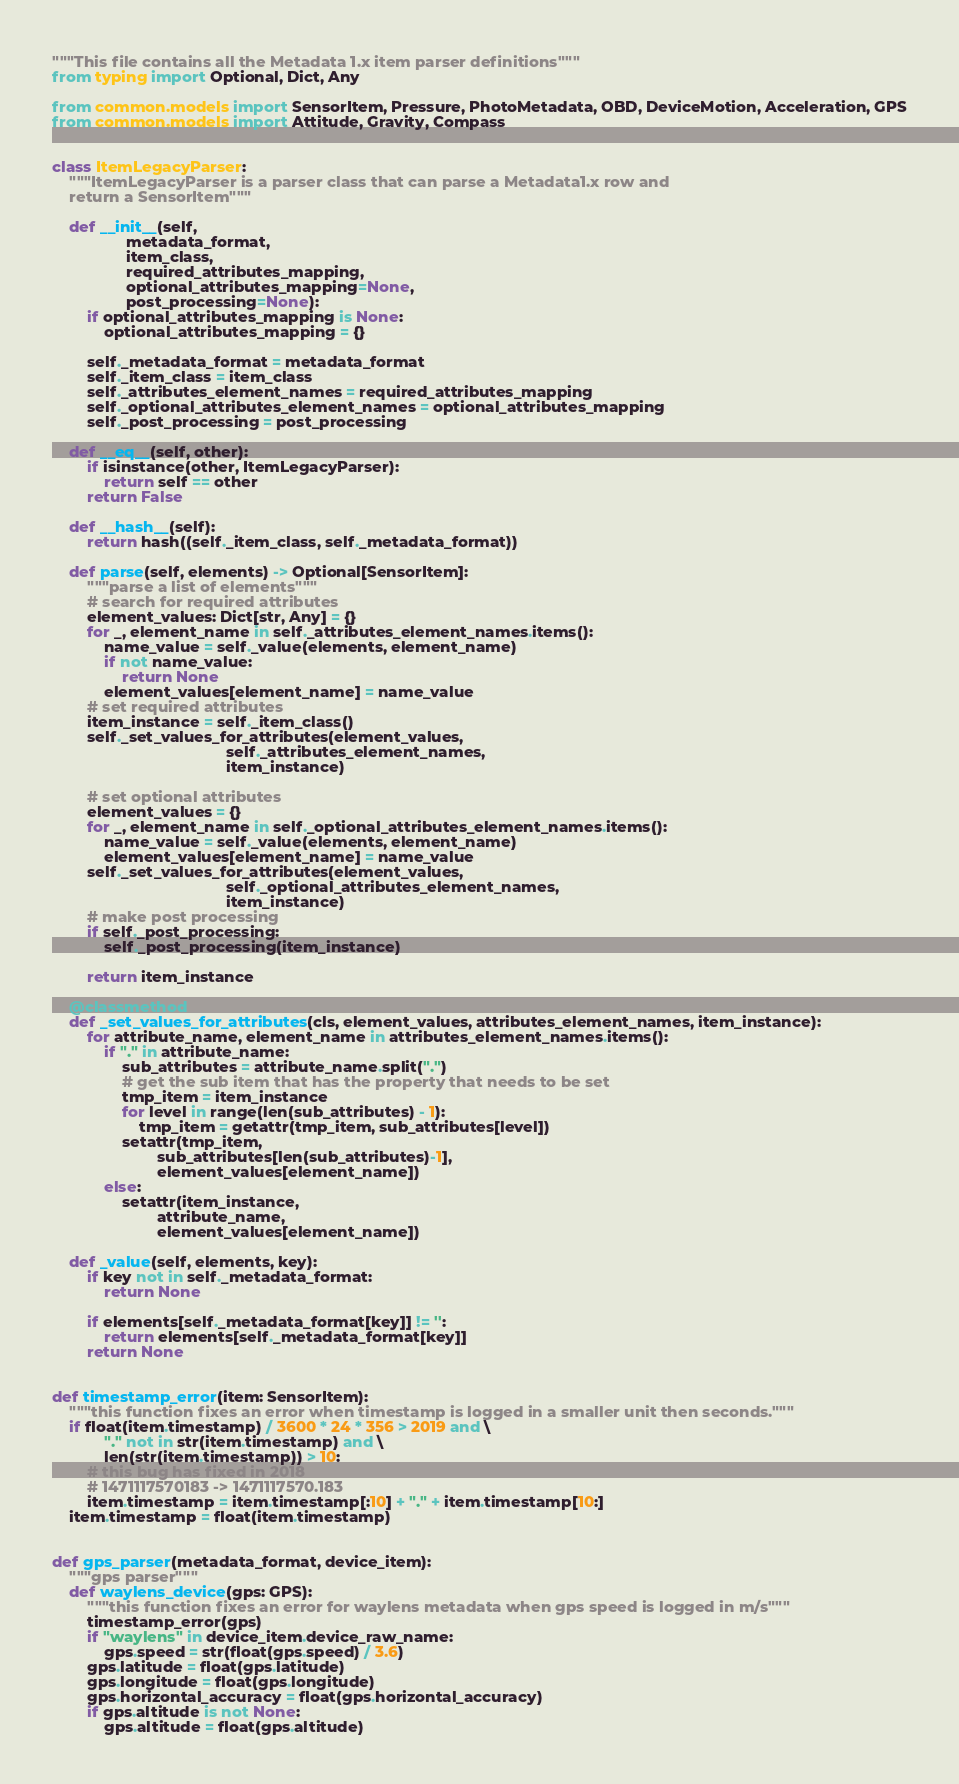Convert code to text. <code><loc_0><loc_0><loc_500><loc_500><_Python_>"""This file contains all the Metadata 1.x item parser definitions"""
from typing import Optional, Dict, Any

from common.models import SensorItem, Pressure, PhotoMetadata, OBD, DeviceMotion, Acceleration, GPS
from common.models import Attitude, Gravity, Compass


class ItemLegacyParser:
    """ItemLegacyParser is a parser class that can parse a Metadata1.x row and
    return a SensorItem"""

    def __init__(self,
                 metadata_format,
                 item_class,
                 required_attributes_mapping,
                 optional_attributes_mapping=None,
                 post_processing=None):
        if optional_attributes_mapping is None:
            optional_attributes_mapping = {}

        self._metadata_format = metadata_format
        self._item_class = item_class
        self._attributes_element_names = required_attributes_mapping
        self._optional_attributes_element_names = optional_attributes_mapping
        self._post_processing = post_processing

    def __eq__(self, other):
        if isinstance(other, ItemLegacyParser):
            return self == other
        return False

    def __hash__(self):
        return hash((self._item_class, self._metadata_format))

    def parse(self, elements) -> Optional[SensorItem]:
        """parse a list of elements"""
        # search for required attributes
        element_values: Dict[str, Any] = {}
        for _, element_name in self._attributes_element_names.items():
            name_value = self._value(elements, element_name)
            if not name_value:
                return None
            element_values[element_name] = name_value
        # set required attributes
        item_instance = self._item_class()
        self._set_values_for_attributes(element_values,
                                        self._attributes_element_names,
                                        item_instance)

        # set optional attributes
        element_values = {}
        for _, element_name in self._optional_attributes_element_names.items():
            name_value = self._value(elements, element_name)
            element_values[element_name] = name_value
        self._set_values_for_attributes(element_values,
                                        self._optional_attributes_element_names,
                                        item_instance)
        # make post processing
        if self._post_processing:
            self._post_processing(item_instance)

        return item_instance

    @classmethod
    def _set_values_for_attributes(cls, element_values, attributes_element_names, item_instance):
        for attribute_name, element_name in attributes_element_names.items():
            if "." in attribute_name:
                sub_attributes = attribute_name.split(".")
                # get the sub item that has the property that needs to be set
                tmp_item = item_instance
                for level in range(len(sub_attributes) - 1):
                    tmp_item = getattr(tmp_item, sub_attributes[level])
                setattr(tmp_item,
                        sub_attributes[len(sub_attributes)-1],
                        element_values[element_name])
            else:
                setattr(item_instance,
                        attribute_name,
                        element_values[element_name])

    def _value(self, elements, key):
        if key not in self._metadata_format:
            return None

        if elements[self._metadata_format[key]] != '':
            return elements[self._metadata_format[key]]
        return None


def timestamp_error(item: SensorItem):
    """this function fixes an error when timestamp is logged in a smaller unit then seconds."""
    if float(item.timestamp) / 3600 * 24 * 356 > 2019 and \
            "." not in str(item.timestamp) and \
            len(str(item.timestamp)) > 10:
        # this bug has fixed in 2018
        # 1471117570183 -> 1471117570.183
        item.timestamp = item.timestamp[:10] + "." + item.timestamp[10:]
    item.timestamp = float(item.timestamp)


def gps_parser(metadata_format, device_item):
    """gps parser"""
    def waylens_device(gps: GPS):
        """this function fixes an error for waylens metadata when gps speed is logged in m/s"""
        timestamp_error(gps)
        if "waylens" in device_item.device_raw_name:
            gps.speed = str(float(gps.speed) / 3.6)
        gps.latitude = float(gps.latitude)
        gps.longitude = float(gps.longitude)
        gps.horizontal_accuracy = float(gps.horizontal_accuracy)
        if gps.altitude is not None:
            gps.altitude = float(gps.altitude)</code> 